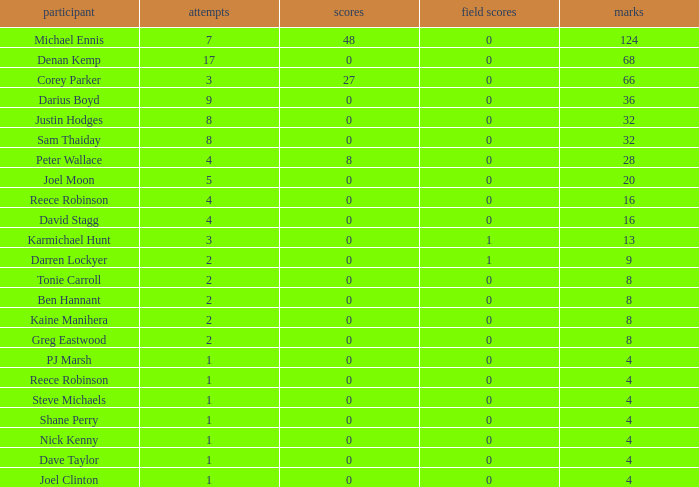What is the lowest tries the player with more than 0 goals, 28 points, and more than 0 field goals have? None. 